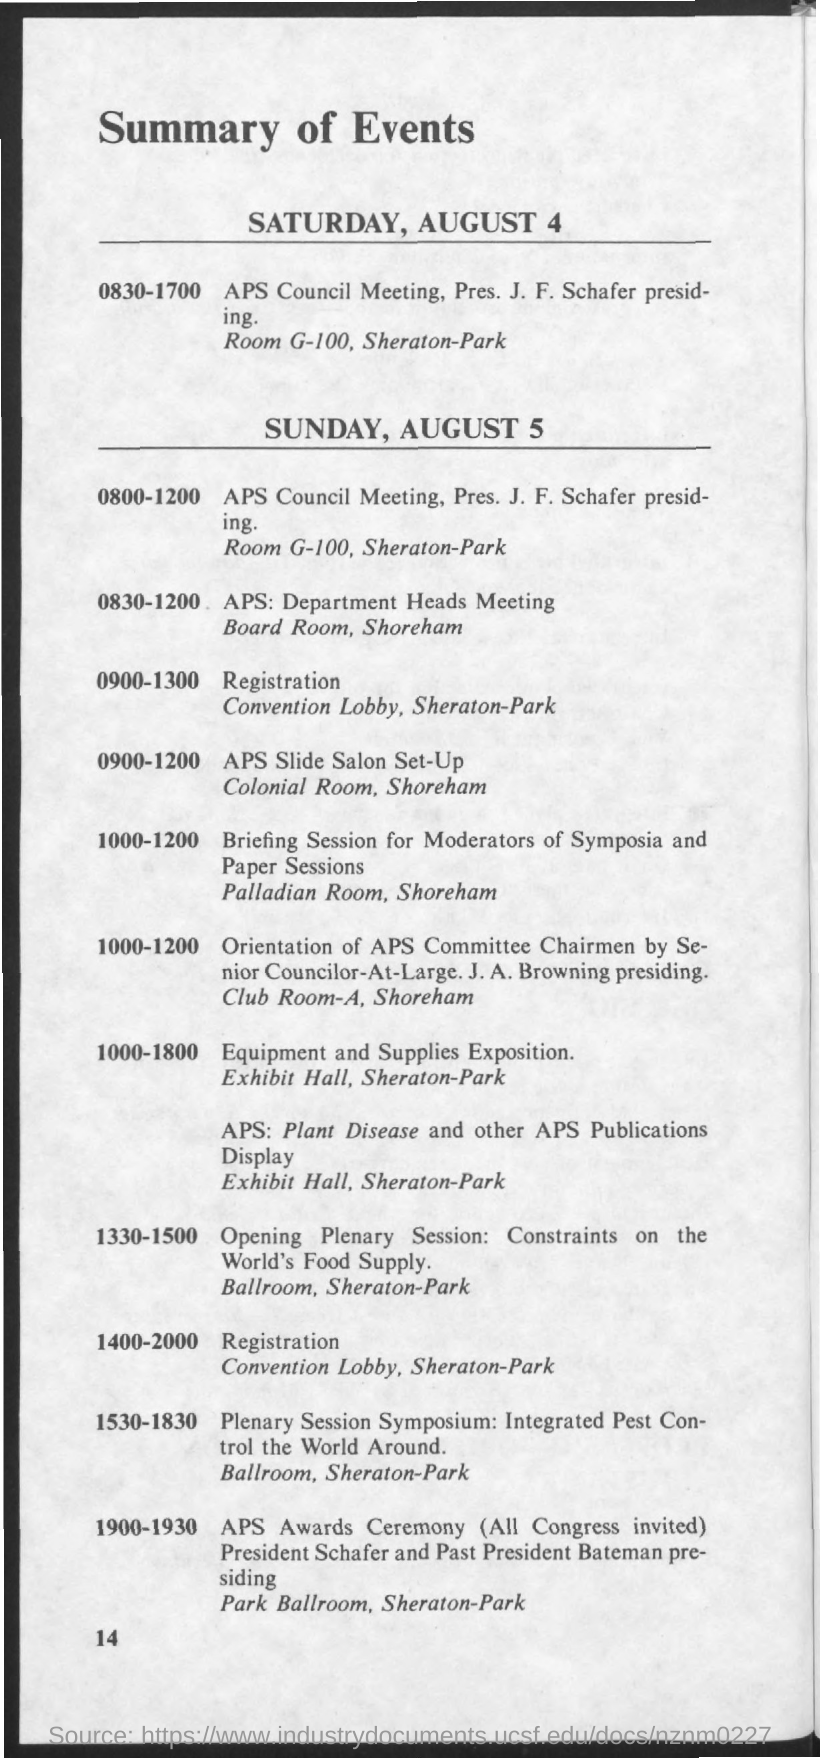What is the date mentioned in the given page ?
Your answer should be compact. Saturday , august 4. 